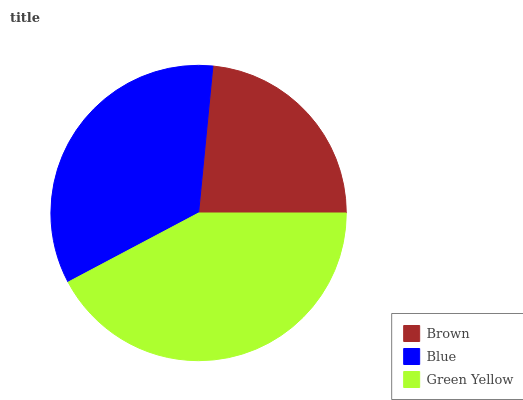Is Brown the minimum?
Answer yes or no. Yes. Is Green Yellow the maximum?
Answer yes or no. Yes. Is Blue the minimum?
Answer yes or no. No. Is Blue the maximum?
Answer yes or no. No. Is Blue greater than Brown?
Answer yes or no. Yes. Is Brown less than Blue?
Answer yes or no. Yes. Is Brown greater than Blue?
Answer yes or no. No. Is Blue less than Brown?
Answer yes or no. No. Is Blue the high median?
Answer yes or no. Yes. Is Blue the low median?
Answer yes or no. Yes. Is Brown the high median?
Answer yes or no. No. Is Brown the low median?
Answer yes or no. No. 